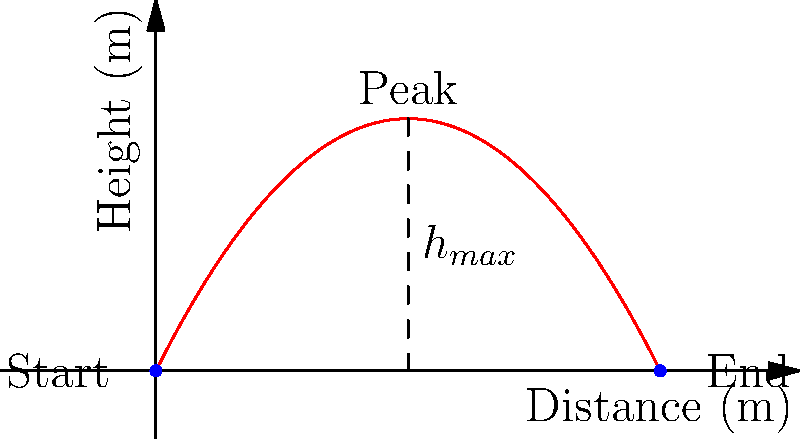At a dog training exhibition, a trainer throws a ball for a retriever to catch. The ball's trajectory forms a parabola as shown in the graph. If the maximum height of the ball is 4 meters and it travels a horizontal distance of 8 meters, what is the initial velocity of the ball in m/s? Assume the ball is thrown from ground level and neglect air resistance. Let's approach this step-by-step:

1) The equation for the trajectory of a projectile is:
   $$y = -\frac{1}{2}g(\frac{x}{v_x})^2 + (\frac{v_y}{v_x})x$$

2) We know:
   - Maximum height (h) = 4 m
   - Horizontal distance (d) = 8 m
   - Initial height (y₀) = 0 m
   - g = 9.8 m/s²

3) At the maximum height, x = d/2 = 4 m. Substituting this into the equation:
   $$4 = -\frac{1}{2}(9.8)(\frac{4}{v_x})^2 + (\frac{v_y}{v_x})4$$

4) The time to reach the maximum height is half the total time of flight. At this point, the vertical velocity is zero:
   $$v_y - gt = 0$$
   $$t = \frac{v_y}{g}$$

5) The total time of flight is twice this:
   $$T = \frac{2v_y}{g}$$

6) We can also find T using the horizontal distance:
   $$d = v_xT$$
   $$8 = v_x(\frac{2v_y}{g})$$
   $$v_x = \frac{4g}{v_y}$$

7) Substituting this back into the equation from step 3:
   $$4 = -\frac{1}{2}(9.8)(\frac{4v_y}{4g})^2 + (\frac{v_y}{4g/v_y})4$$
   $$4 = -\frac{v_y^2}{8g} + \frac{v_y^2}{g}$$
   $$4 = \frac{7v_y^2}{8g}$$

8) Solving for v_y:
   $$v_y = \sqrt{\frac{32g}{7}} \approx 7.67 \text{ m/s}$$

9) Now we can find v_x:
   $$v_x = \frac{4g}{v_y} \approx 5.11 \text{ m/s}$$

10) The initial velocity is:
    $$v_0 = \sqrt{v_x^2 + v_y^2} \approx 9.22 \text{ m/s}$$
Answer: 9.22 m/s 